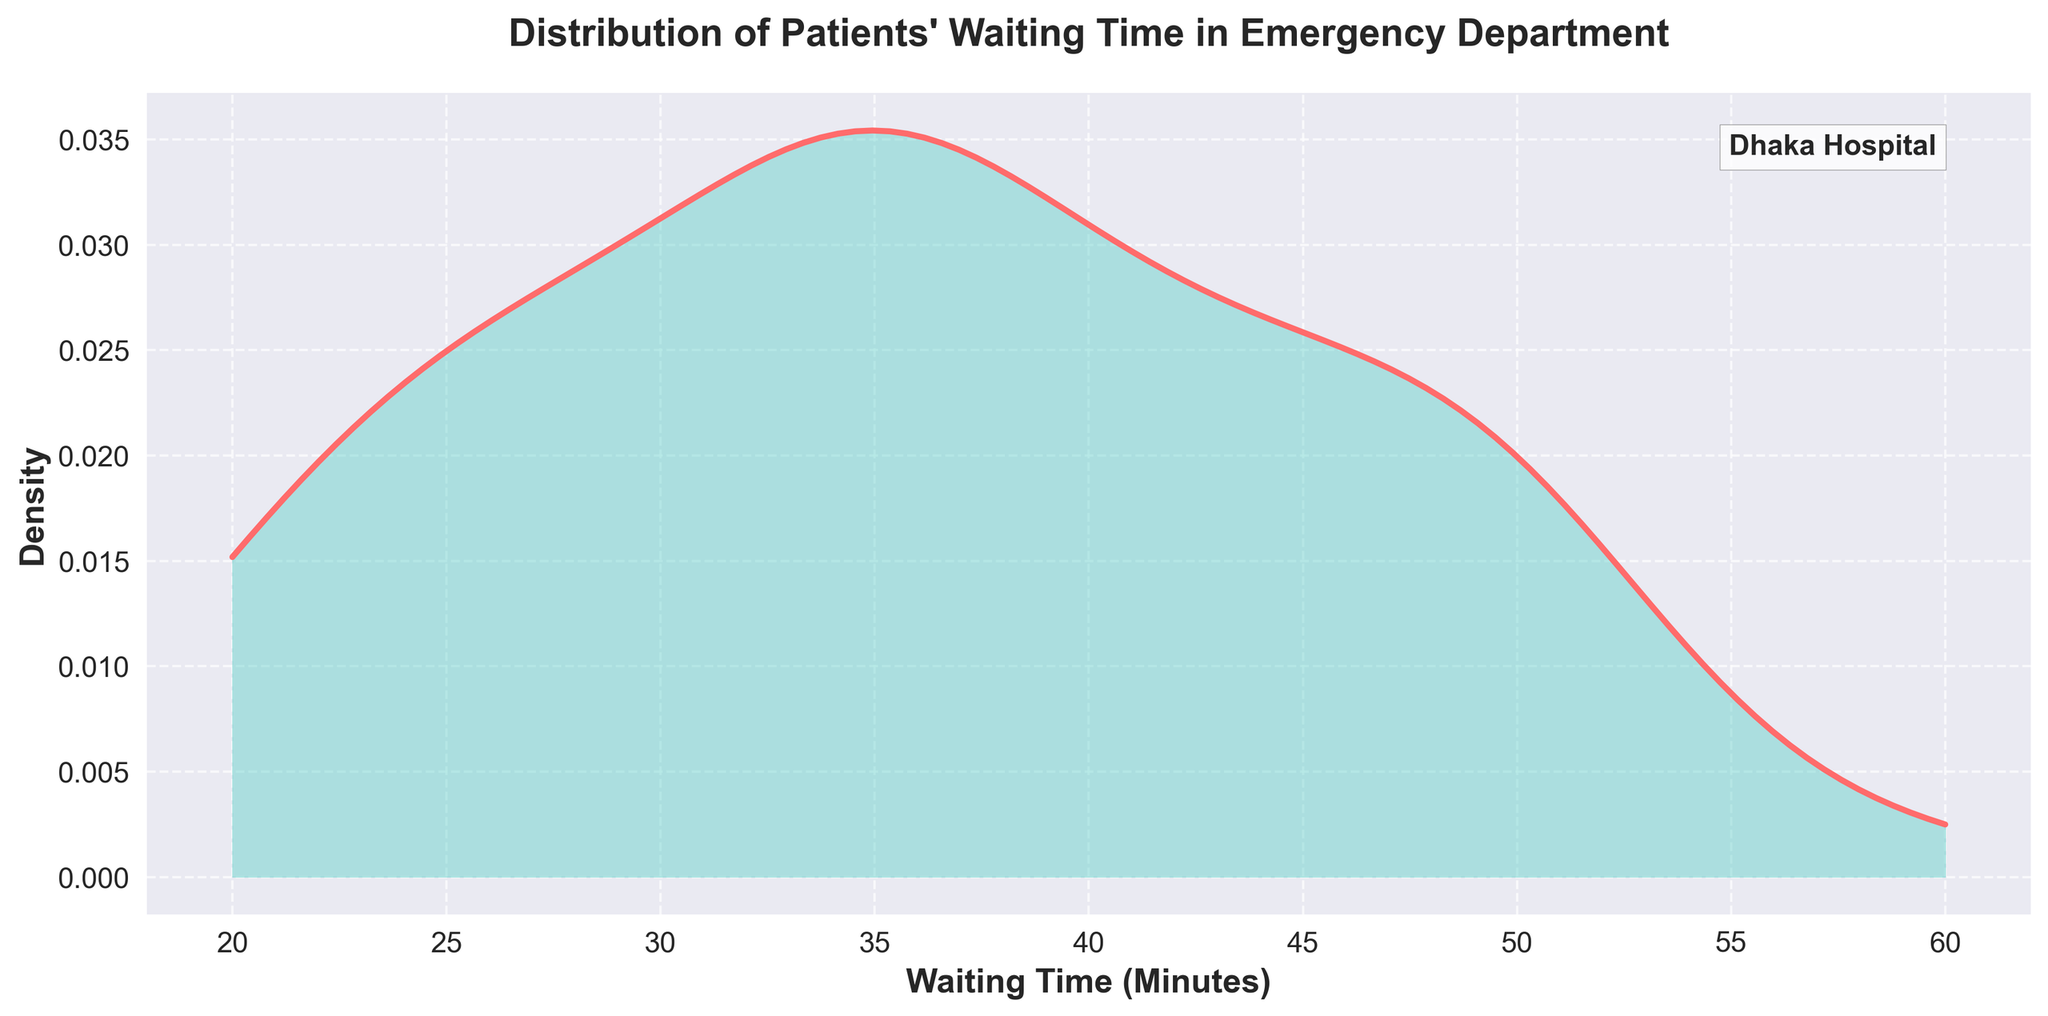What is the title of the density plot? The title of the plot is usually placed at the top of a chart and provides a brief description of the chart's content.
Answer: Distribution of Patients' Waiting Time in Emergency Department What are the labels on the x-axis and y-axis? The x-axis label is typically at the bottom, and the y-axis label is positioned along the vertical axis. The x-axis label here represents the measurement being analyzed, which is "Waiting Time (Minutes)." The y-axis label represents the density value.
Answer: Waiting Time (Minutes); Density Which color is used to plot the line representing the density? Observing the figure, the line representing the density is easily distinguishable by its unique color.
Answer: Red During which hour range do patients generally experience the highest density of waiting times? By examining the peak of the density curve, we can infer the period during which waiting times are most concentrated. The peak indicates the time range with the highest probability of waiting times occurring.
Answer: ~20 to 40 minutes What does the shaded area under the curve represent? In a density plot, the shaded area under the curve represents the distribution's probability density. It shows the distribution’s total probability over the range of waiting times. The area itself does not provide specific probabilities without integration but gives a visual sense of where the values are concentrated.
Answer: Probability density distribution How does the density of waiting times change as the waiting time increases from 10 minutes to 70 minutes? By observing the slope of the density line, we can determine how the probability densities fluctuate with increasing waiting times.
Answer: Density increases, peaks around 20-40 minutes, then decreases What is the approximate maximum density value observed in the plot? The highest point on the density curve indicates the maximum density value observed in the data's distribution.
Answer: ~0.025 Is there a specific waiting time at which the density is zero? By examining the endpoints and dips to the baseline on the density graph, we can determine if any waiting times have a zero probability density.
Answer: No How evenly distributed are the waiting times in the emergency department? A relatively flat density distribution would indicate an even spread, while a steep peak would suggest concentration around certain values. Observing the density curve informs about the spread or clustering of waiting times.
Answer: Moderately concentrated around 20-40 minutes 